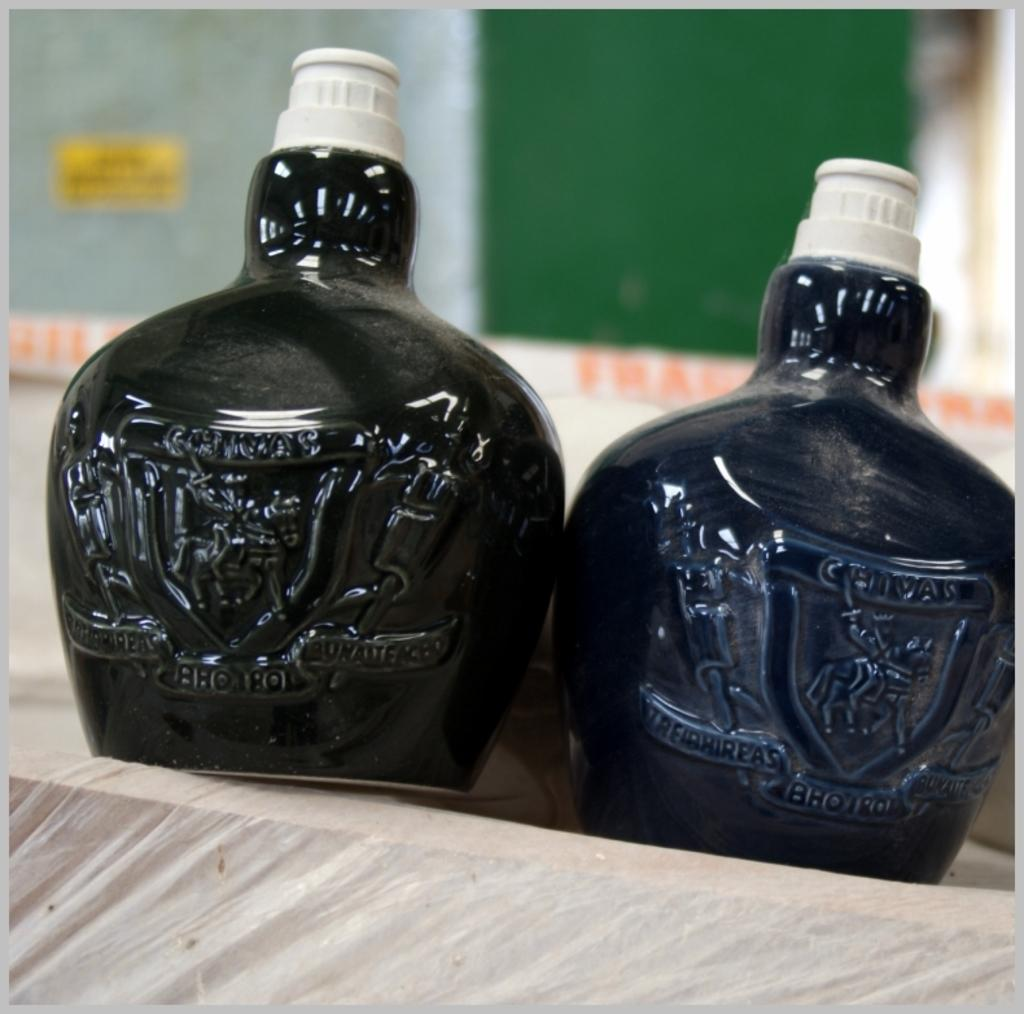<image>
Create a compact narrative representing the image presented. a small bottle with the name of chivas on it 